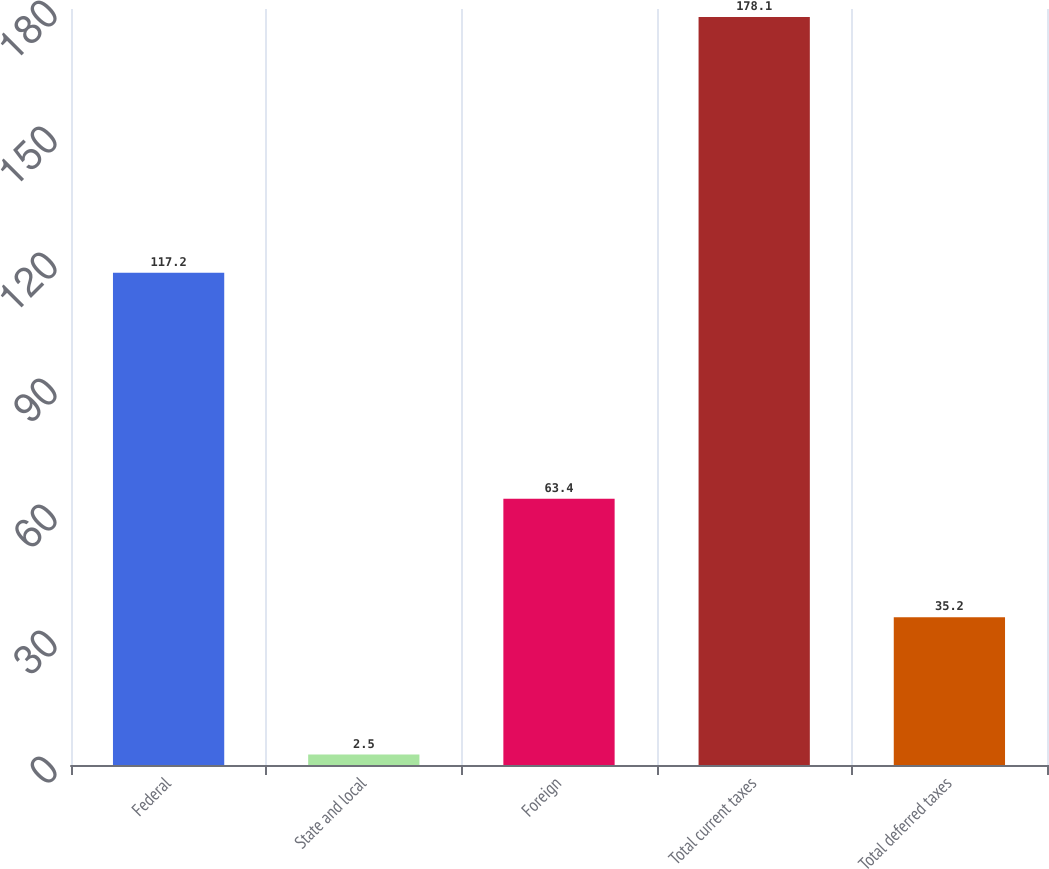Convert chart to OTSL. <chart><loc_0><loc_0><loc_500><loc_500><bar_chart><fcel>Federal<fcel>State and local<fcel>Foreign<fcel>Total current taxes<fcel>Total deferred taxes<nl><fcel>117.2<fcel>2.5<fcel>63.4<fcel>178.1<fcel>35.2<nl></chart> 